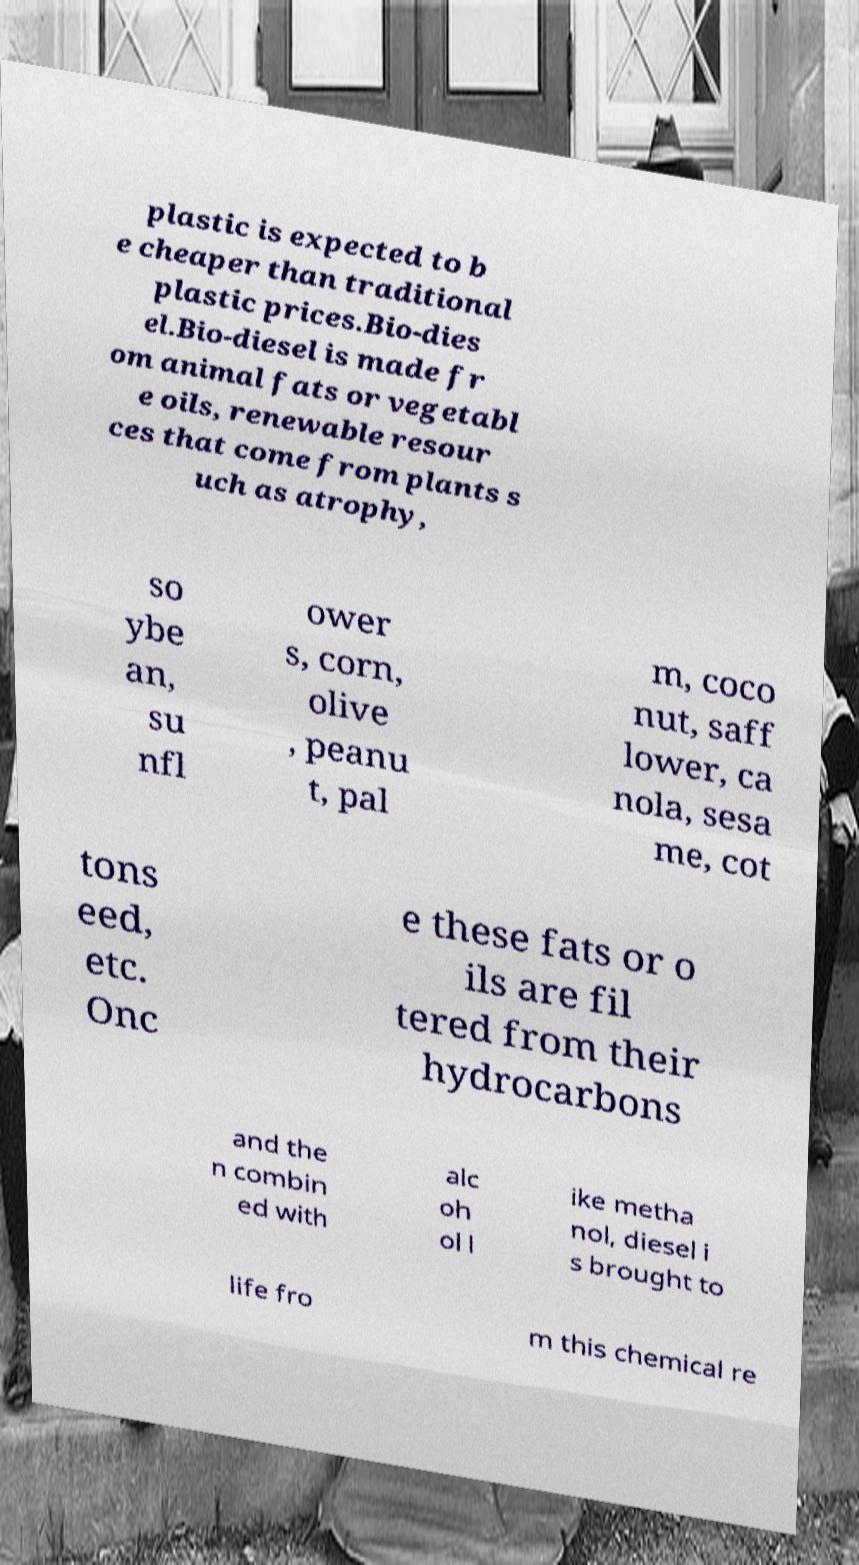Could you extract and type out the text from this image? plastic is expected to b e cheaper than traditional plastic prices.Bio-dies el.Bio-diesel is made fr om animal fats or vegetabl e oils, renewable resour ces that come from plants s uch as atrophy, so ybe an, su nfl ower s, corn, olive , peanu t, pal m, coco nut, saff lower, ca nola, sesa me, cot tons eed, etc. Onc e these fats or o ils are fil tered from their hydrocarbons and the n combin ed with alc oh ol l ike metha nol, diesel i s brought to life fro m this chemical re 